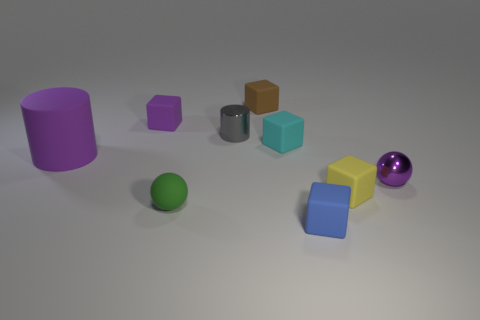Subtract all blue cubes. How many cubes are left? 4 Subtract all small blue blocks. How many blocks are left? 4 Subtract all gray blocks. Subtract all brown cylinders. How many blocks are left? 5 Add 1 cyan metal blocks. How many objects exist? 10 Subtract all balls. How many objects are left? 7 Subtract all small cyan rubber things. Subtract all tiny gray things. How many objects are left? 7 Add 1 brown rubber things. How many brown rubber things are left? 2 Add 9 small brown rubber things. How many small brown rubber things exist? 10 Subtract 1 blue blocks. How many objects are left? 8 